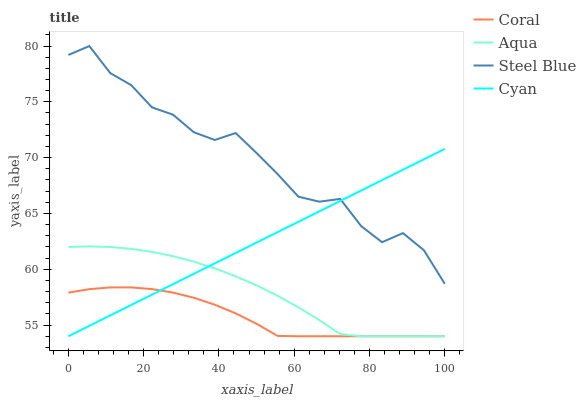Does Coral have the minimum area under the curve?
Answer yes or no. Yes. Does Steel Blue have the maximum area under the curve?
Answer yes or no. Yes. Does Aqua have the minimum area under the curve?
Answer yes or no. No. Does Aqua have the maximum area under the curve?
Answer yes or no. No. Is Cyan the smoothest?
Answer yes or no. Yes. Is Steel Blue the roughest?
Answer yes or no. Yes. Is Coral the smoothest?
Answer yes or no. No. Is Coral the roughest?
Answer yes or no. No. Does Cyan have the lowest value?
Answer yes or no. Yes. Does Steel Blue have the lowest value?
Answer yes or no. No. Does Steel Blue have the highest value?
Answer yes or no. Yes. Does Aqua have the highest value?
Answer yes or no. No. Is Aqua less than Steel Blue?
Answer yes or no. Yes. Is Steel Blue greater than Aqua?
Answer yes or no. Yes. Does Aqua intersect Coral?
Answer yes or no. Yes. Is Aqua less than Coral?
Answer yes or no. No. Is Aqua greater than Coral?
Answer yes or no. No. Does Aqua intersect Steel Blue?
Answer yes or no. No. 